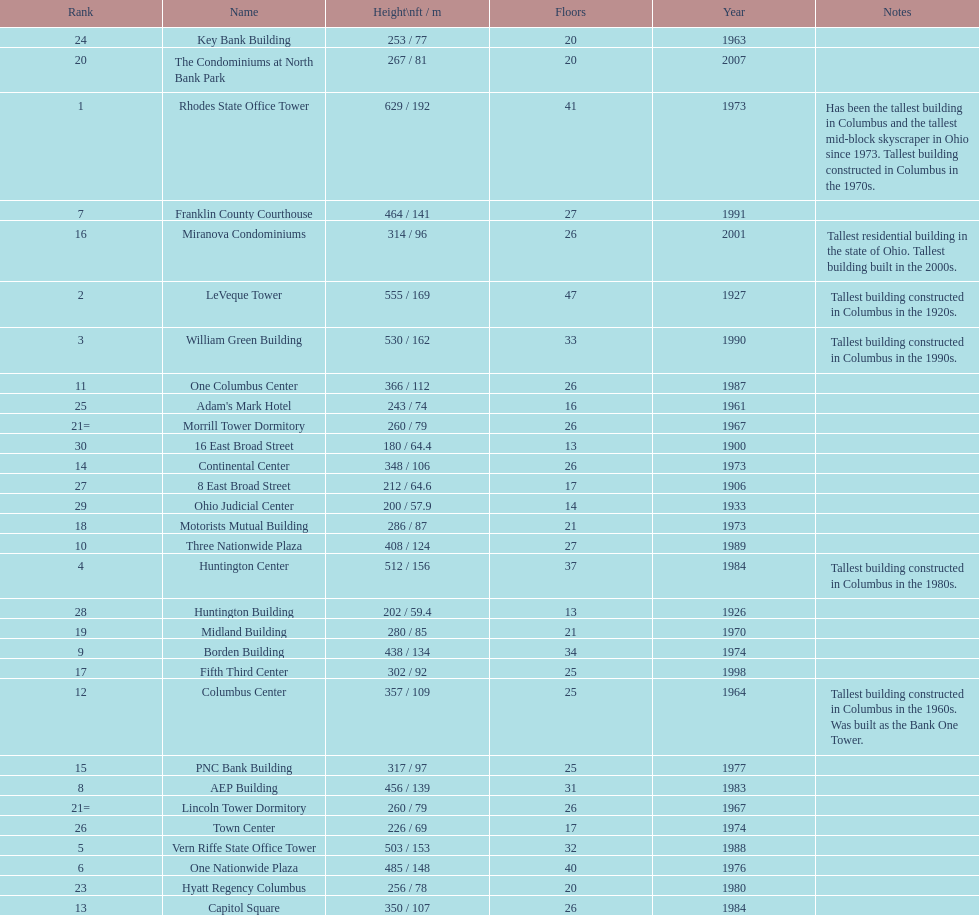How many floors does the capitol square have? 26. 